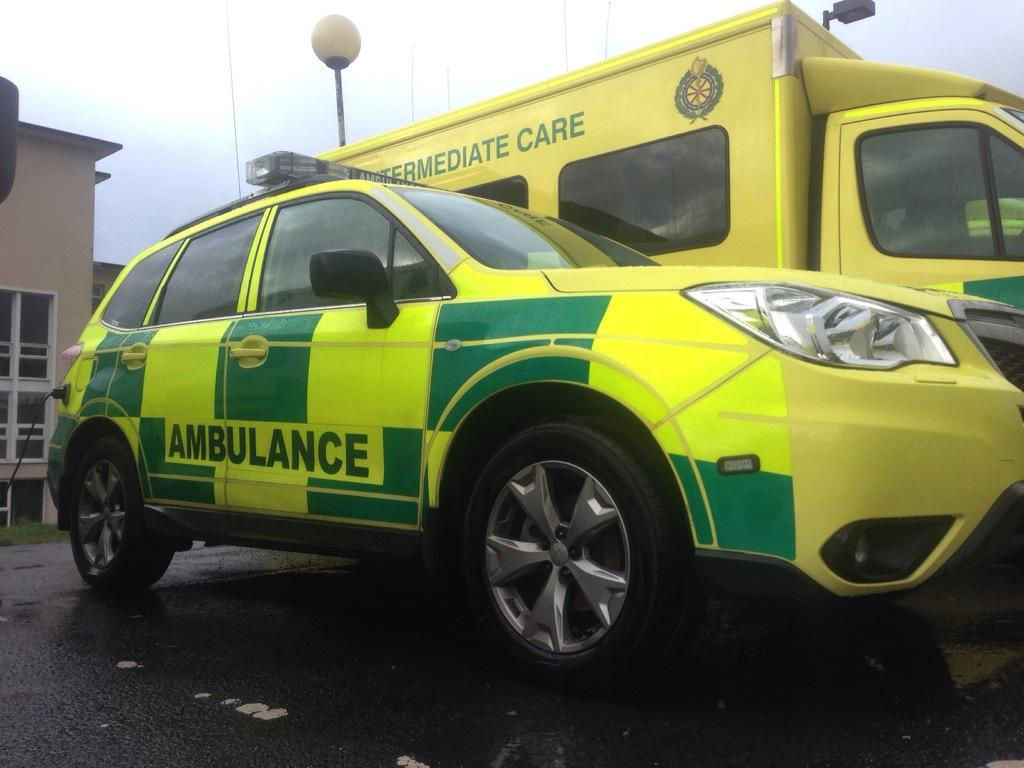Provide a one-sentence caption for the provided image. Two emergency vehicles, both ambulences they are yellow and green. 